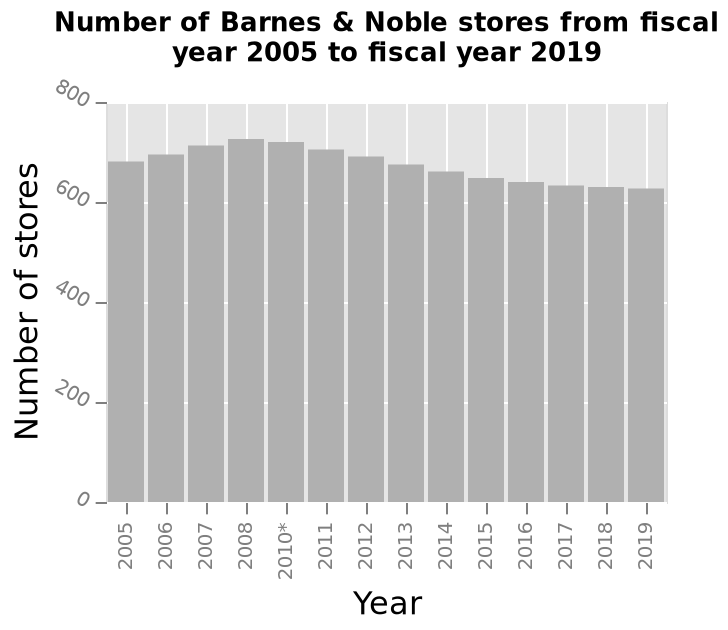<image>
Has the number of stores remained relatively stable over time?  Yes, there has been very little movement in the number of stores throughout the years. Is there a noticeable fluctuation in the number of stores over time?  No, there has been very little movement in the number of stores throughout the years. What kind of diagram is being referred to in the figure? The figure refers to a bar diagram. 